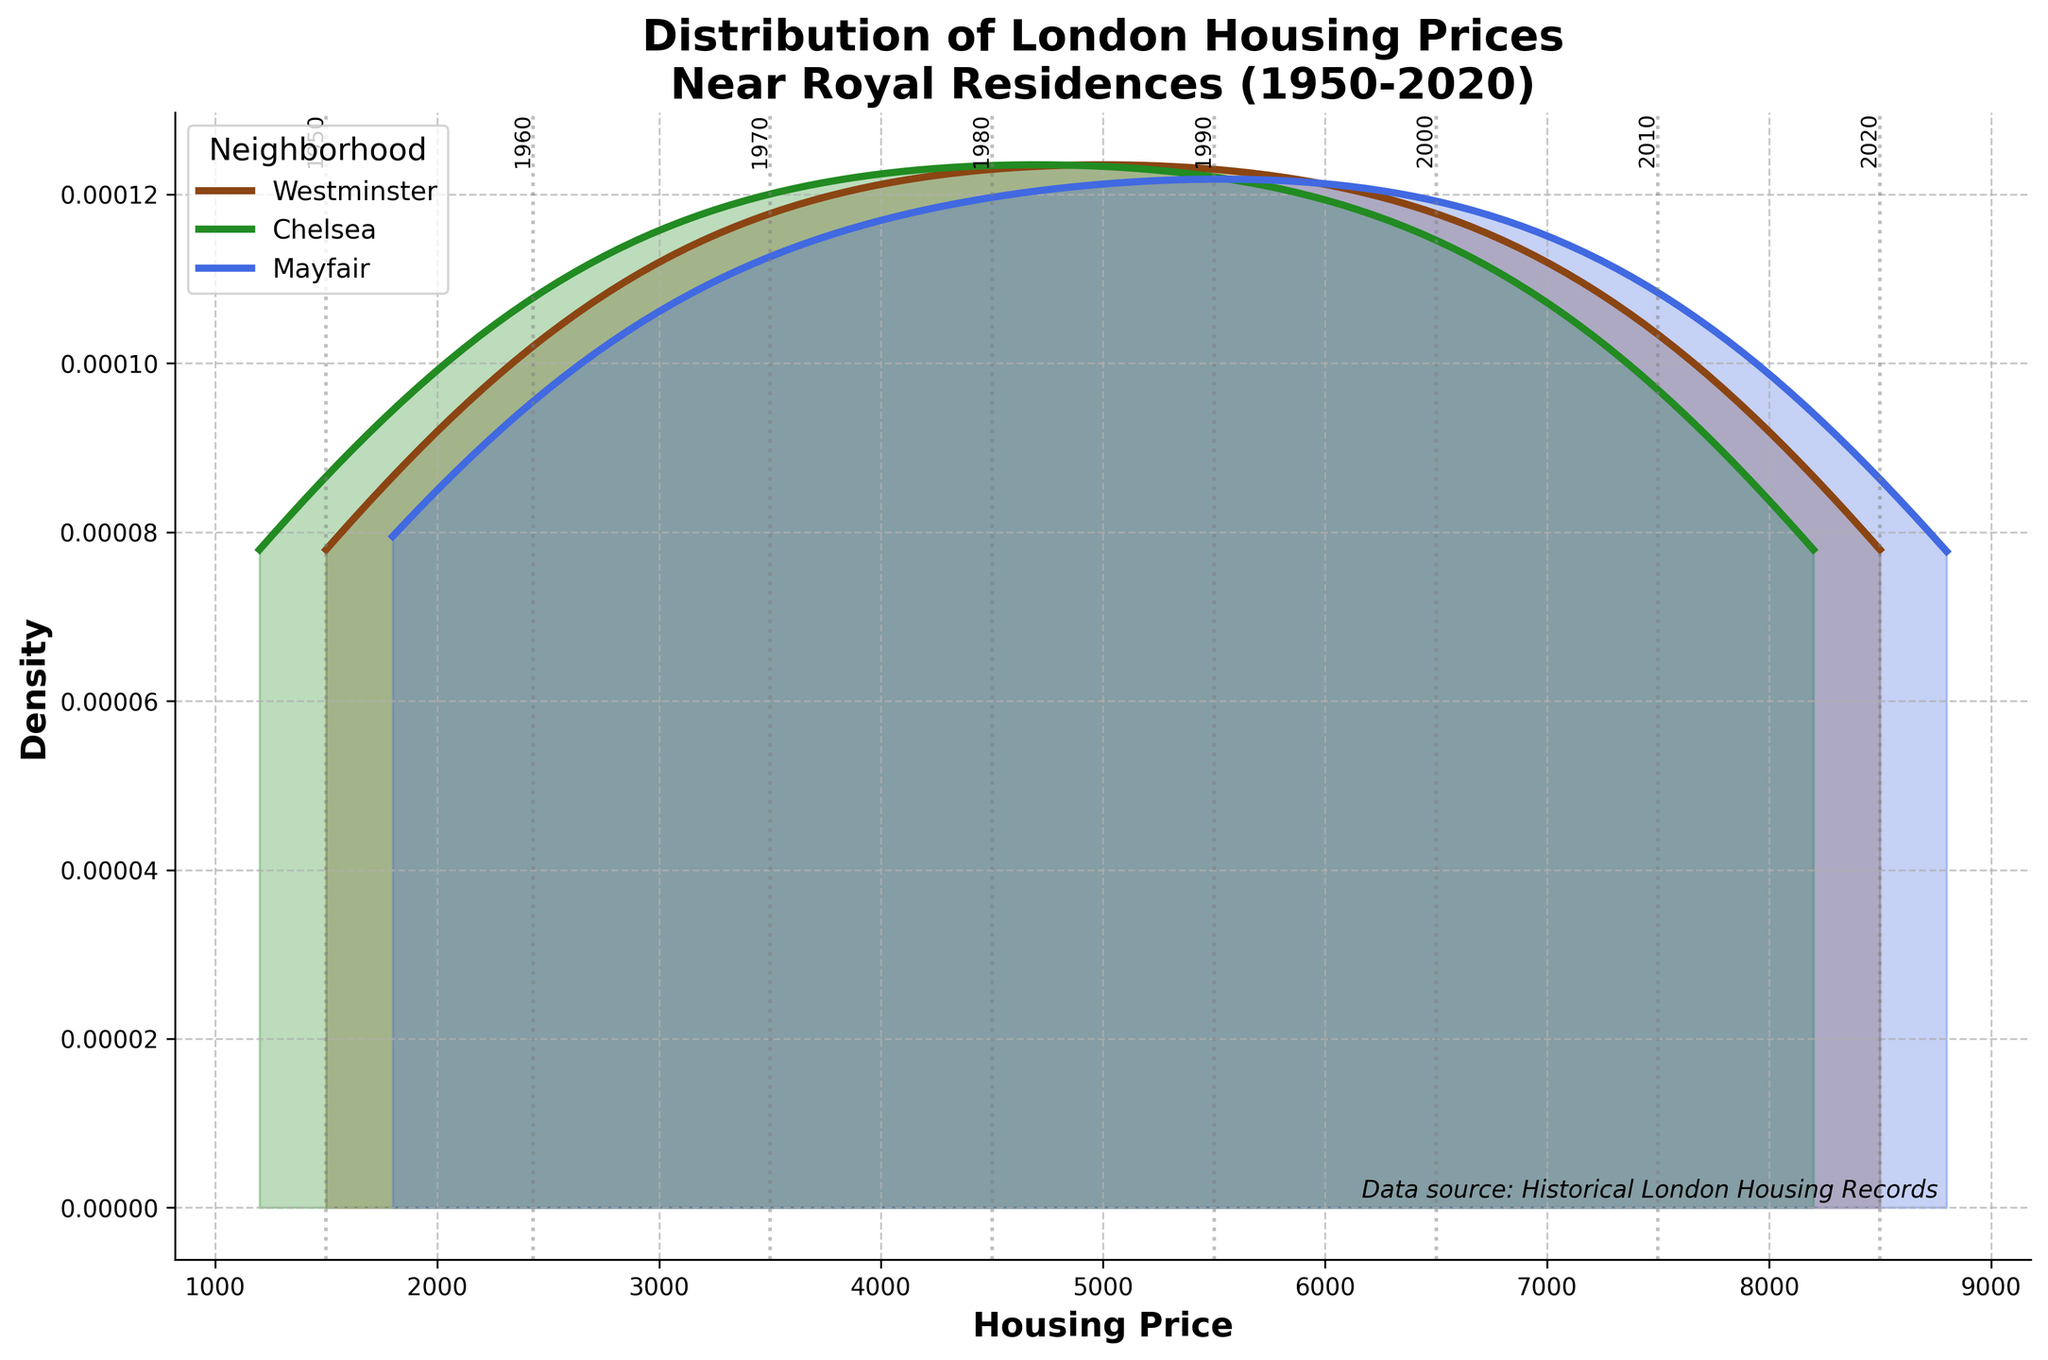Which neighborhood has the highest density peak? Observing the density curves, the highest peak indicates the area with the densest prices. Mayfair shows the tallest peak in the density plot.
Answer: Mayfair How do the housing prices of Chelsea compare to Westminster in 2020? By looking at the density areas and the vertical gray lines representing each decade, Chelsea's prices in 2020 are slightly lower than those of Westminster.
Answer: Chelsea's prices are slightly lower What can you infer about housing price trends over the decades? By comparing the density curves across the decades, we notice a shift to the right, indicating that housing prices have generally increased over time from 1950 to 2020.
Answer: Prices increased over time Which decade shows the largest increase in housing prices? By examining the distance between the vertical lines representing each decade, the largest gap (indicative of the highest increase) occurs between the 1950s and 1960s.
Answer: 1950s to 1960s Are there any years when the housing prices in all neighborhoods were similar? Analyzing the density curves, particularly where they overlap, shows that in the 1950s and 1960s, the prices were more comparable across all neighborhoods.
Answer: 1950s and 1960s Which neighborhood shows the greatest variation in housing prices over the decades? The wider the density curve, the greater the variation in prices. Mayfair's curve spreads more over the price range than others, indicating greater variation.
Answer: Mayfair Does Mayfair consistently have higher housing prices than Chelsea? By comparing the density curves of both neighborhoods across decades, Mayfair consistently shows higher price peaks than Chelsea.
Answer: Yes What is the most significant historical event that might have influenced housing prices in Westminster in 1980? Historical context in the figure indicates "Near Buckingham Palace," potentially reflecting changes or renovations in the royal residence's status influencing the prices around it.
Answer: Renovations or changes near Buckingham Palace 